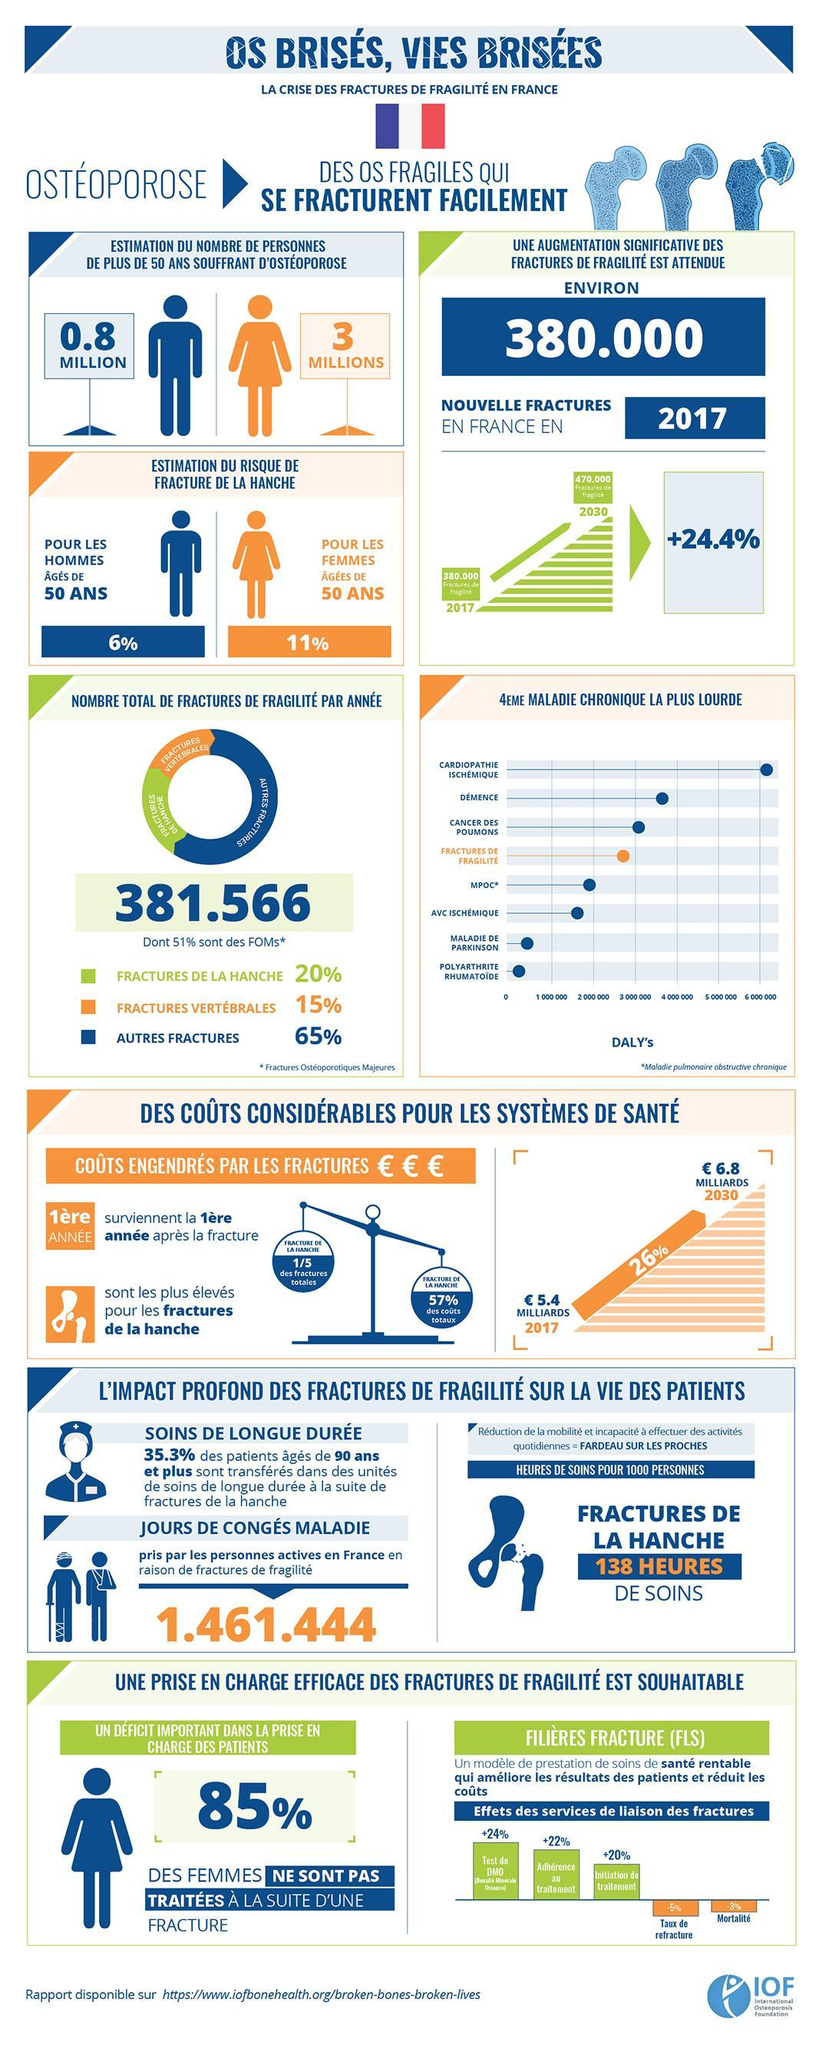How many images representing females is shown here ?
Answer the question with a short phrase. 3 